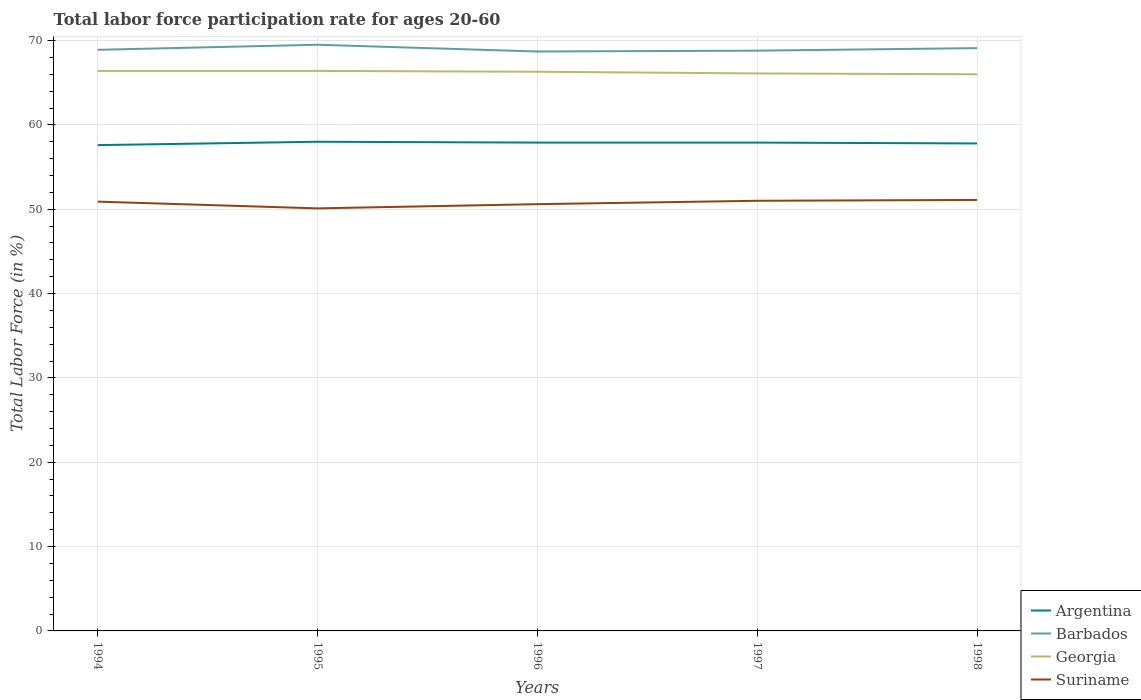Is the number of lines equal to the number of legend labels?
Give a very brief answer. Yes. Across all years, what is the maximum labor force participation rate in Argentina?
Give a very brief answer. 57.6. In which year was the labor force participation rate in Argentina maximum?
Offer a very short reply. 1994. What is the total labor force participation rate in Georgia in the graph?
Give a very brief answer. 0.1. What is the difference between the highest and the second highest labor force participation rate in Suriname?
Provide a short and direct response. 1. Is the labor force participation rate in Barbados strictly greater than the labor force participation rate in Suriname over the years?
Provide a short and direct response. No. What is the difference between two consecutive major ticks on the Y-axis?
Your answer should be very brief. 10. Does the graph contain any zero values?
Your answer should be very brief. No. Does the graph contain grids?
Make the answer very short. Yes. What is the title of the graph?
Provide a succinct answer. Total labor force participation rate for ages 20-60. Does "Greenland" appear as one of the legend labels in the graph?
Your response must be concise. No. What is the label or title of the Y-axis?
Make the answer very short. Total Labor Force (in %). What is the Total Labor Force (in %) of Argentina in 1994?
Your answer should be compact. 57.6. What is the Total Labor Force (in %) in Barbados in 1994?
Provide a short and direct response. 68.9. What is the Total Labor Force (in %) in Georgia in 1994?
Your answer should be very brief. 66.4. What is the Total Labor Force (in %) in Suriname in 1994?
Your response must be concise. 50.9. What is the Total Labor Force (in %) in Barbados in 1995?
Your answer should be compact. 69.5. What is the Total Labor Force (in %) in Georgia in 1995?
Provide a succinct answer. 66.4. What is the Total Labor Force (in %) in Suriname in 1995?
Your answer should be compact. 50.1. What is the Total Labor Force (in %) in Argentina in 1996?
Provide a succinct answer. 57.9. What is the Total Labor Force (in %) of Barbados in 1996?
Your response must be concise. 68.7. What is the Total Labor Force (in %) of Georgia in 1996?
Make the answer very short. 66.3. What is the Total Labor Force (in %) of Suriname in 1996?
Your response must be concise. 50.6. What is the Total Labor Force (in %) of Argentina in 1997?
Your answer should be compact. 57.9. What is the Total Labor Force (in %) of Barbados in 1997?
Your response must be concise. 68.8. What is the Total Labor Force (in %) of Georgia in 1997?
Your answer should be compact. 66.1. What is the Total Labor Force (in %) of Argentina in 1998?
Keep it short and to the point. 57.8. What is the Total Labor Force (in %) in Barbados in 1998?
Provide a succinct answer. 69.1. What is the Total Labor Force (in %) in Suriname in 1998?
Provide a short and direct response. 51.1. Across all years, what is the maximum Total Labor Force (in %) of Argentina?
Make the answer very short. 58. Across all years, what is the maximum Total Labor Force (in %) of Barbados?
Give a very brief answer. 69.5. Across all years, what is the maximum Total Labor Force (in %) of Georgia?
Give a very brief answer. 66.4. Across all years, what is the maximum Total Labor Force (in %) in Suriname?
Your response must be concise. 51.1. Across all years, what is the minimum Total Labor Force (in %) in Argentina?
Your response must be concise. 57.6. Across all years, what is the minimum Total Labor Force (in %) of Barbados?
Keep it short and to the point. 68.7. Across all years, what is the minimum Total Labor Force (in %) of Georgia?
Provide a short and direct response. 66. Across all years, what is the minimum Total Labor Force (in %) of Suriname?
Offer a terse response. 50.1. What is the total Total Labor Force (in %) in Argentina in the graph?
Keep it short and to the point. 289.2. What is the total Total Labor Force (in %) in Barbados in the graph?
Offer a terse response. 345. What is the total Total Labor Force (in %) of Georgia in the graph?
Your answer should be compact. 331.2. What is the total Total Labor Force (in %) of Suriname in the graph?
Give a very brief answer. 253.7. What is the difference between the Total Labor Force (in %) of Georgia in 1994 and that in 1995?
Provide a succinct answer. 0. What is the difference between the Total Labor Force (in %) of Suriname in 1994 and that in 1995?
Your response must be concise. 0.8. What is the difference between the Total Labor Force (in %) of Barbados in 1994 and that in 1996?
Provide a short and direct response. 0.2. What is the difference between the Total Labor Force (in %) in Georgia in 1994 and that in 1996?
Offer a terse response. 0.1. What is the difference between the Total Labor Force (in %) in Barbados in 1994 and that in 1997?
Your answer should be very brief. 0.1. What is the difference between the Total Labor Force (in %) in Georgia in 1994 and that in 1997?
Offer a terse response. 0.3. What is the difference between the Total Labor Force (in %) in Georgia in 1994 and that in 1998?
Give a very brief answer. 0.4. What is the difference between the Total Labor Force (in %) in Argentina in 1995 and that in 1996?
Provide a short and direct response. 0.1. What is the difference between the Total Labor Force (in %) in Georgia in 1995 and that in 1996?
Make the answer very short. 0.1. What is the difference between the Total Labor Force (in %) in Suriname in 1995 and that in 1996?
Give a very brief answer. -0.5. What is the difference between the Total Labor Force (in %) in Barbados in 1995 and that in 1997?
Give a very brief answer. 0.7. What is the difference between the Total Labor Force (in %) of Georgia in 1995 and that in 1997?
Provide a short and direct response. 0.3. What is the difference between the Total Labor Force (in %) of Suriname in 1995 and that in 1997?
Your response must be concise. -0.9. What is the difference between the Total Labor Force (in %) in Georgia in 1995 and that in 1998?
Make the answer very short. 0.4. What is the difference between the Total Labor Force (in %) of Suriname in 1995 and that in 1998?
Your response must be concise. -1. What is the difference between the Total Labor Force (in %) of Argentina in 1996 and that in 1997?
Your response must be concise. 0. What is the difference between the Total Labor Force (in %) of Barbados in 1996 and that in 1997?
Give a very brief answer. -0.1. What is the difference between the Total Labor Force (in %) in Suriname in 1996 and that in 1997?
Your answer should be very brief. -0.4. What is the difference between the Total Labor Force (in %) in Barbados in 1996 and that in 1998?
Offer a very short reply. -0.4. What is the difference between the Total Labor Force (in %) in Georgia in 1996 and that in 1998?
Give a very brief answer. 0.3. What is the difference between the Total Labor Force (in %) of Suriname in 1996 and that in 1998?
Your response must be concise. -0.5. What is the difference between the Total Labor Force (in %) in Barbados in 1997 and that in 1998?
Give a very brief answer. -0.3. What is the difference between the Total Labor Force (in %) of Georgia in 1997 and that in 1998?
Ensure brevity in your answer.  0.1. What is the difference between the Total Labor Force (in %) of Suriname in 1997 and that in 1998?
Your response must be concise. -0.1. What is the difference between the Total Labor Force (in %) of Argentina in 1994 and the Total Labor Force (in %) of Barbados in 1995?
Your response must be concise. -11.9. What is the difference between the Total Labor Force (in %) in Argentina in 1994 and the Total Labor Force (in %) in Georgia in 1995?
Make the answer very short. -8.8. What is the difference between the Total Labor Force (in %) in Georgia in 1994 and the Total Labor Force (in %) in Suriname in 1995?
Give a very brief answer. 16.3. What is the difference between the Total Labor Force (in %) of Argentina in 1994 and the Total Labor Force (in %) of Barbados in 1996?
Your answer should be compact. -11.1. What is the difference between the Total Labor Force (in %) in Argentina in 1994 and the Total Labor Force (in %) in Georgia in 1996?
Your response must be concise. -8.7. What is the difference between the Total Labor Force (in %) of Barbados in 1994 and the Total Labor Force (in %) of Georgia in 1996?
Ensure brevity in your answer.  2.6. What is the difference between the Total Labor Force (in %) of Georgia in 1994 and the Total Labor Force (in %) of Suriname in 1996?
Provide a short and direct response. 15.8. What is the difference between the Total Labor Force (in %) in Argentina in 1994 and the Total Labor Force (in %) in Georgia in 1997?
Provide a succinct answer. -8.5. What is the difference between the Total Labor Force (in %) in Barbados in 1994 and the Total Labor Force (in %) in Georgia in 1997?
Offer a very short reply. 2.8. What is the difference between the Total Labor Force (in %) of Barbados in 1994 and the Total Labor Force (in %) of Suriname in 1997?
Offer a terse response. 17.9. What is the difference between the Total Labor Force (in %) in Georgia in 1994 and the Total Labor Force (in %) in Suriname in 1997?
Your answer should be compact. 15.4. What is the difference between the Total Labor Force (in %) of Barbados in 1994 and the Total Labor Force (in %) of Georgia in 1998?
Provide a short and direct response. 2.9. What is the difference between the Total Labor Force (in %) in Georgia in 1994 and the Total Labor Force (in %) in Suriname in 1998?
Your answer should be compact. 15.3. What is the difference between the Total Labor Force (in %) in Argentina in 1995 and the Total Labor Force (in %) in Georgia in 1996?
Give a very brief answer. -8.3. What is the difference between the Total Labor Force (in %) in Barbados in 1995 and the Total Labor Force (in %) in Georgia in 1996?
Offer a terse response. 3.2. What is the difference between the Total Labor Force (in %) in Georgia in 1995 and the Total Labor Force (in %) in Suriname in 1996?
Ensure brevity in your answer.  15.8. What is the difference between the Total Labor Force (in %) of Argentina in 1995 and the Total Labor Force (in %) of Barbados in 1997?
Offer a terse response. -10.8. What is the difference between the Total Labor Force (in %) in Argentina in 1995 and the Total Labor Force (in %) in Georgia in 1997?
Give a very brief answer. -8.1. What is the difference between the Total Labor Force (in %) in Argentina in 1995 and the Total Labor Force (in %) in Barbados in 1998?
Offer a terse response. -11.1. What is the difference between the Total Labor Force (in %) of Argentina in 1995 and the Total Labor Force (in %) of Suriname in 1998?
Provide a succinct answer. 6.9. What is the difference between the Total Labor Force (in %) in Barbados in 1995 and the Total Labor Force (in %) in Suriname in 1998?
Provide a short and direct response. 18.4. What is the difference between the Total Labor Force (in %) of Georgia in 1995 and the Total Labor Force (in %) of Suriname in 1998?
Provide a succinct answer. 15.3. What is the difference between the Total Labor Force (in %) in Georgia in 1996 and the Total Labor Force (in %) in Suriname in 1998?
Offer a very short reply. 15.2. What is the difference between the Total Labor Force (in %) of Barbados in 1997 and the Total Labor Force (in %) of Suriname in 1998?
Give a very brief answer. 17.7. What is the difference between the Total Labor Force (in %) in Georgia in 1997 and the Total Labor Force (in %) in Suriname in 1998?
Offer a terse response. 15. What is the average Total Labor Force (in %) in Argentina per year?
Keep it short and to the point. 57.84. What is the average Total Labor Force (in %) of Barbados per year?
Offer a terse response. 69. What is the average Total Labor Force (in %) in Georgia per year?
Provide a succinct answer. 66.24. What is the average Total Labor Force (in %) in Suriname per year?
Offer a terse response. 50.74. In the year 1994, what is the difference between the Total Labor Force (in %) in Argentina and Total Labor Force (in %) in Barbados?
Provide a succinct answer. -11.3. In the year 1994, what is the difference between the Total Labor Force (in %) of Argentina and Total Labor Force (in %) of Georgia?
Provide a succinct answer. -8.8. In the year 1994, what is the difference between the Total Labor Force (in %) of Barbados and Total Labor Force (in %) of Georgia?
Offer a terse response. 2.5. In the year 1994, what is the difference between the Total Labor Force (in %) of Georgia and Total Labor Force (in %) of Suriname?
Offer a very short reply. 15.5. In the year 1995, what is the difference between the Total Labor Force (in %) in Barbados and Total Labor Force (in %) in Georgia?
Ensure brevity in your answer.  3.1. In the year 1996, what is the difference between the Total Labor Force (in %) of Argentina and Total Labor Force (in %) of Barbados?
Provide a succinct answer. -10.8. In the year 1996, what is the difference between the Total Labor Force (in %) of Argentina and Total Labor Force (in %) of Suriname?
Offer a very short reply. 7.3. In the year 1996, what is the difference between the Total Labor Force (in %) in Georgia and Total Labor Force (in %) in Suriname?
Give a very brief answer. 15.7. In the year 1997, what is the difference between the Total Labor Force (in %) in Argentina and Total Labor Force (in %) in Barbados?
Keep it short and to the point. -10.9. In the year 1997, what is the difference between the Total Labor Force (in %) of Barbados and Total Labor Force (in %) of Suriname?
Make the answer very short. 17.8. In the year 1998, what is the difference between the Total Labor Force (in %) in Argentina and Total Labor Force (in %) in Georgia?
Keep it short and to the point. -8.2. In the year 1998, what is the difference between the Total Labor Force (in %) in Barbados and Total Labor Force (in %) in Georgia?
Provide a short and direct response. 3.1. What is the ratio of the Total Labor Force (in %) of Argentina in 1994 to that in 1995?
Your answer should be very brief. 0.99. What is the ratio of the Total Labor Force (in %) in Georgia in 1994 to that in 1995?
Ensure brevity in your answer.  1. What is the ratio of the Total Labor Force (in %) of Suriname in 1994 to that in 1995?
Offer a terse response. 1.02. What is the ratio of the Total Labor Force (in %) in Argentina in 1994 to that in 1996?
Ensure brevity in your answer.  0.99. What is the ratio of the Total Labor Force (in %) in Barbados in 1994 to that in 1996?
Keep it short and to the point. 1. What is the ratio of the Total Labor Force (in %) of Georgia in 1994 to that in 1996?
Offer a very short reply. 1. What is the ratio of the Total Labor Force (in %) in Suriname in 1994 to that in 1996?
Provide a short and direct response. 1.01. What is the ratio of the Total Labor Force (in %) in Argentina in 1994 to that in 1997?
Keep it short and to the point. 0.99. What is the ratio of the Total Labor Force (in %) of Barbados in 1994 to that in 1997?
Offer a terse response. 1. What is the ratio of the Total Labor Force (in %) in Barbados in 1994 to that in 1998?
Provide a short and direct response. 1. What is the ratio of the Total Labor Force (in %) of Suriname in 1994 to that in 1998?
Give a very brief answer. 1. What is the ratio of the Total Labor Force (in %) of Argentina in 1995 to that in 1996?
Give a very brief answer. 1. What is the ratio of the Total Labor Force (in %) in Barbados in 1995 to that in 1996?
Give a very brief answer. 1.01. What is the ratio of the Total Labor Force (in %) of Georgia in 1995 to that in 1996?
Ensure brevity in your answer.  1. What is the ratio of the Total Labor Force (in %) in Argentina in 1995 to that in 1997?
Make the answer very short. 1. What is the ratio of the Total Labor Force (in %) in Barbados in 1995 to that in 1997?
Your response must be concise. 1.01. What is the ratio of the Total Labor Force (in %) of Suriname in 1995 to that in 1997?
Provide a short and direct response. 0.98. What is the ratio of the Total Labor Force (in %) in Suriname in 1995 to that in 1998?
Offer a very short reply. 0.98. What is the ratio of the Total Labor Force (in %) of Argentina in 1996 to that in 1997?
Ensure brevity in your answer.  1. What is the ratio of the Total Labor Force (in %) of Georgia in 1996 to that in 1997?
Your response must be concise. 1. What is the ratio of the Total Labor Force (in %) in Suriname in 1996 to that in 1998?
Provide a succinct answer. 0.99. What is the ratio of the Total Labor Force (in %) in Argentina in 1997 to that in 1998?
Ensure brevity in your answer.  1. What is the ratio of the Total Labor Force (in %) of Barbados in 1997 to that in 1998?
Your answer should be compact. 1. What is the ratio of the Total Labor Force (in %) of Suriname in 1997 to that in 1998?
Your answer should be very brief. 1. What is the difference between the highest and the second highest Total Labor Force (in %) in Argentina?
Offer a very short reply. 0.1. What is the difference between the highest and the second highest Total Labor Force (in %) in Barbados?
Your response must be concise. 0.4. What is the difference between the highest and the second highest Total Labor Force (in %) in Georgia?
Provide a succinct answer. 0. What is the difference between the highest and the lowest Total Labor Force (in %) of Georgia?
Provide a short and direct response. 0.4. What is the difference between the highest and the lowest Total Labor Force (in %) of Suriname?
Ensure brevity in your answer.  1. 